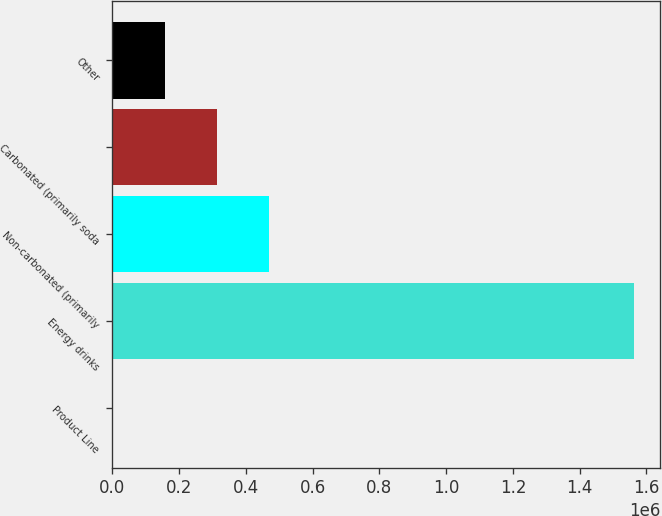<chart> <loc_0><loc_0><loc_500><loc_500><bar_chart><fcel>Product Line<fcel>Energy drinks<fcel>Non-carbonated (primarily<fcel>Carbonated (primarily soda<fcel>Other<nl><fcel>2011<fcel>1.56333e+06<fcel>470407<fcel>314275<fcel>158143<nl></chart> 